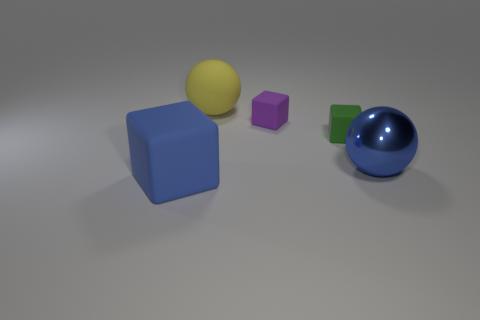Is there any other thing that has the same material as the blue sphere?
Give a very brief answer. No. How many green objects are either tiny matte objects or matte blocks?
Your response must be concise. 1. How many shiny things are blocks or objects?
Offer a terse response. 1. Is there a purple block?
Provide a short and direct response. Yes. Do the small green thing and the blue matte object have the same shape?
Your response must be concise. Yes. There is a yellow rubber object that is to the right of the blue thing that is to the left of the big blue sphere; how many large things are in front of it?
Offer a very short reply. 2. What is the large thing that is both in front of the small purple cube and on the left side of the large blue metal thing made of?
Ensure brevity in your answer.  Rubber. What is the color of the matte cube that is left of the green rubber thing and behind the blue ball?
Offer a very short reply. Purple. Is there any other thing of the same color as the big block?
Provide a succinct answer. Yes. What shape is the rubber object to the left of the large ball to the left of the matte cube behind the green block?
Ensure brevity in your answer.  Cube. 